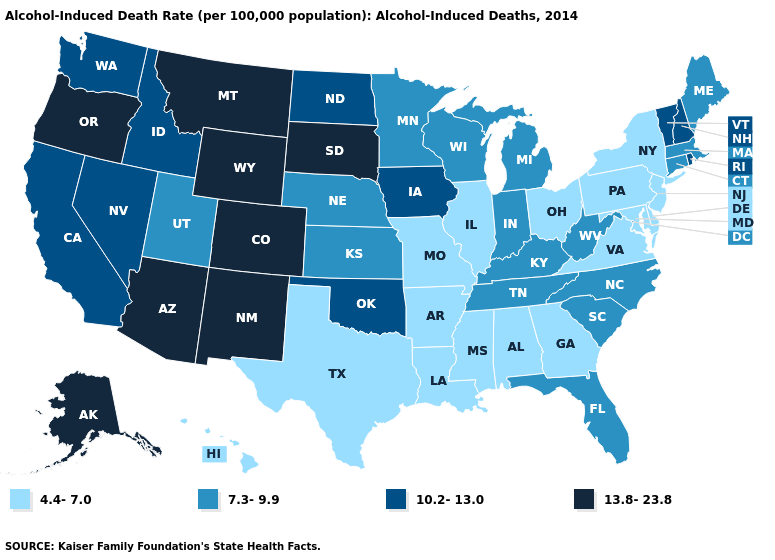Does North Carolina have the lowest value in the South?
Write a very short answer. No. What is the value of Montana?
Concise answer only. 13.8-23.8. What is the highest value in states that border Utah?
Keep it brief. 13.8-23.8. Does Wisconsin have the same value as Kentucky?
Concise answer only. Yes. What is the value of Texas?
Give a very brief answer. 4.4-7.0. Among the states that border Delaware , which have the lowest value?
Be succinct. Maryland, New Jersey, Pennsylvania. Which states hav the highest value in the South?
Answer briefly. Oklahoma. Does Nevada have the highest value in the USA?
Keep it brief. No. Name the states that have a value in the range 10.2-13.0?
Concise answer only. California, Idaho, Iowa, Nevada, New Hampshire, North Dakota, Oklahoma, Rhode Island, Vermont, Washington. Does Georgia have the same value as Ohio?
Short answer required. Yes. What is the value of West Virginia?
Short answer required. 7.3-9.9. What is the highest value in states that border Nebraska?
Give a very brief answer. 13.8-23.8. Which states have the highest value in the USA?
Concise answer only. Alaska, Arizona, Colorado, Montana, New Mexico, Oregon, South Dakota, Wyoming. Name the states that have a value in the range 10.2-13.0?
Short answer required. California, Idaho, Iowa, Nevada, New Hampshire, North Dakota, Oklahoma, Rhode Island, Vermont, Washington. 